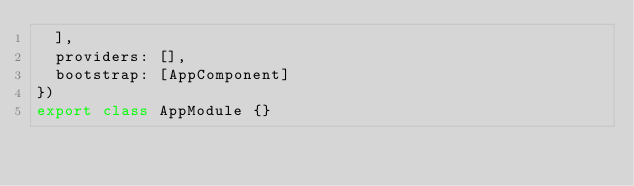<code> <loc_0><loc_0><loc_500><loc_500><_TypeScript_>  ],
  providers: [],
  bootstrap: [AppComponent]
})
export class AppModule {}
</code> 